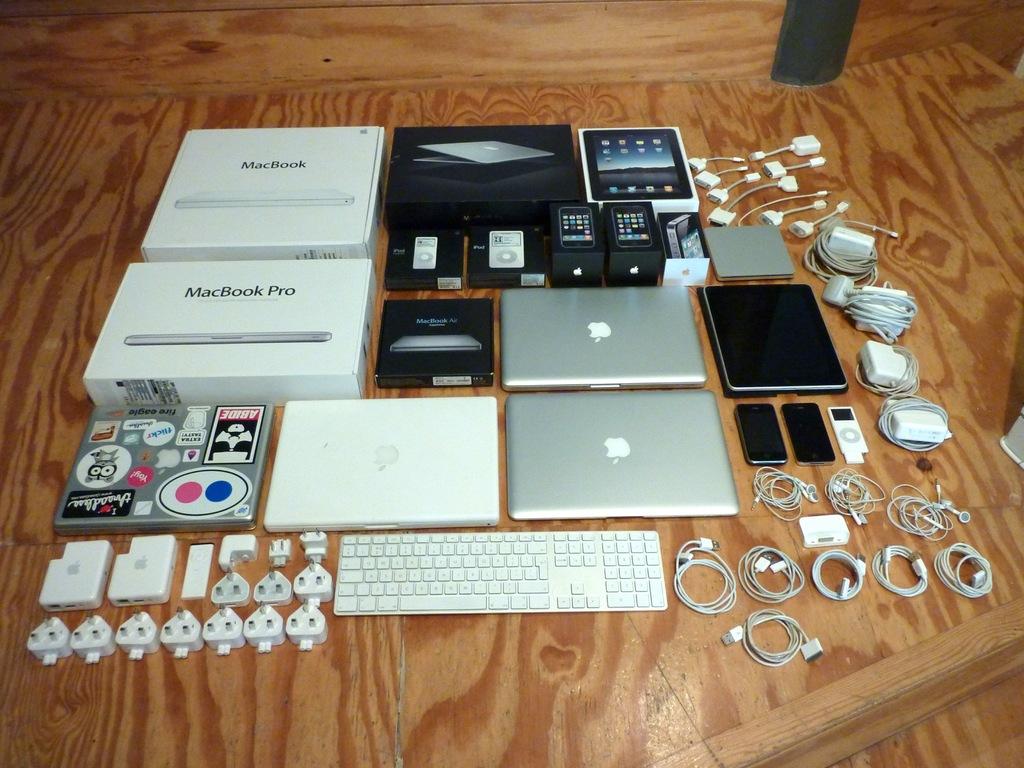What model is the computer on the top left?
Offer a very short reply. Macbook. 